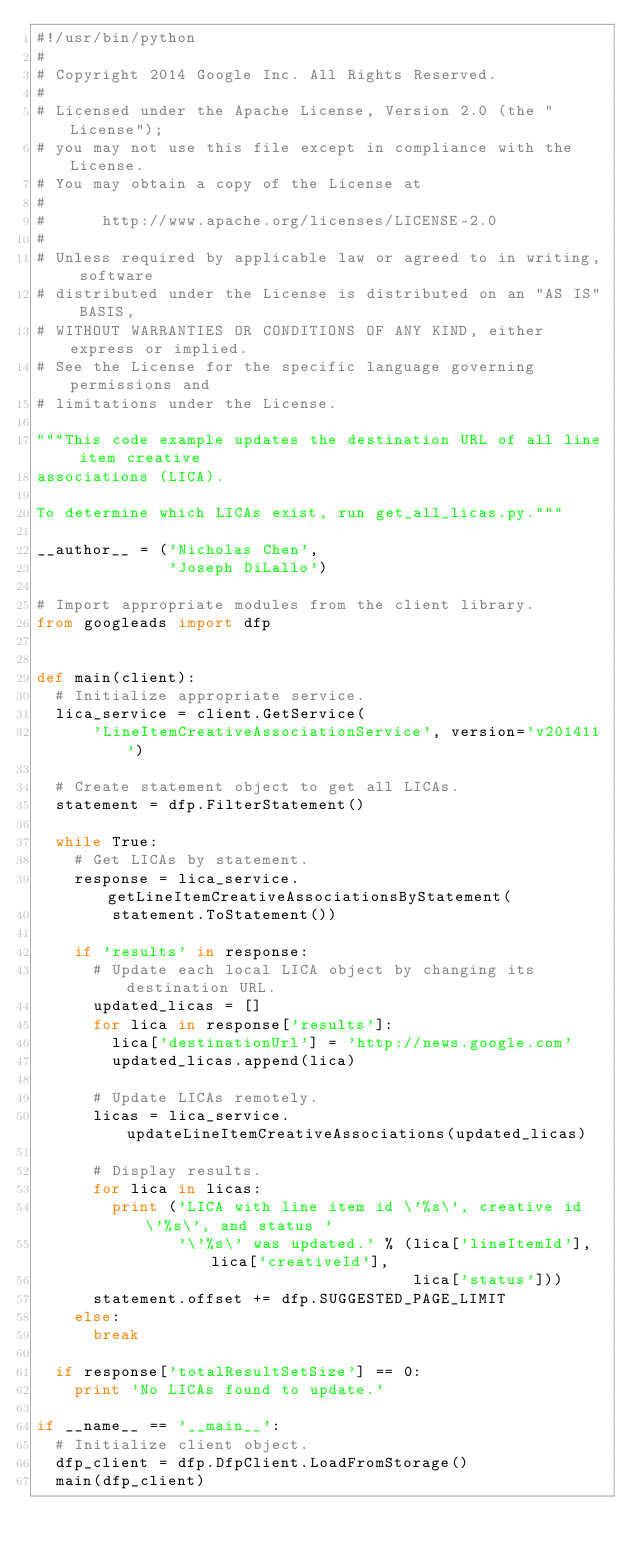<code> <loc_0><loc_0><loc_500><loc_500><_Python_>#!/usr/bin/python
#
# Copyright 2014 Google Inc. All Rights Reserved.
#
# Licensed under the Apache License, Version 2.0 (the "License");
# you may not use this file except in compliance with the License.
# You may obtain a copy of the License at
#
#      http://www.apache.org/licenses/LICENSE-2.0
#
# Unless required by applicable law or agreed to in writing, software
# distributed under the License is distributed on an "AS IS" BASIS,
# WITHOUT WARRANTIES OR CONDITIONS OF ANY KIND, either express or implied.
# See the License for the specific language governing permissions and
# limitations under the License.

"""This code example updates the destination URL of all line item creative
associations (LICA).

To determine which LICAs exist, run get_all_licas.py."""

__author__ = ('Nicholas Chen',
              'Joseph DiLallo')

# Import appropriate modules from the client library.
from googleads import dfp


def main(client):
  # Initialize appropriate service.
  lica_service = client.GetService(
      'LineItemCreativeAssociationService', version='v201411')

  # Create statement object to get all LICAs.
  statement = dfp.FilterStatement()

  while True:
    # Get LICAs by statement.
    response = lica_service.getLineItemCreativeAssociationsByStatement(
        statement.ToStatement())

    if 'results' in response:
      # Update each local LICA object by changing its destination URL.
      updated_licas = []
      for lica in response['results']:
        lica['destinationUrl'] = 'http://news.google.com'
        updated_licas.append(lica)

      # Update LICAs remotely.
      licas = lica_service.updateLineItemCreativeAssociations(updated_licas)

      # Display results.
      for lica in licas:
        print ('LICA with line item id \'%s\', creative id \'%s\', and status '
               '\'%s\' was updated.' % (lica['lineItemId'], lica['creativeId'],
                                        lica['status']))
      statement.offset += dfp.SUGGESTED_PAGE_LIMIT
    else:
      break

  if response['totalResultSetSize'] == 0:
    print 'No LICAs found to update.'

if __name__ == '__main__':
  # Initialize client object.
  dfp_client = dfp.DfpClient.LoadFromStorage()
  main(dfp_client)
</code> 